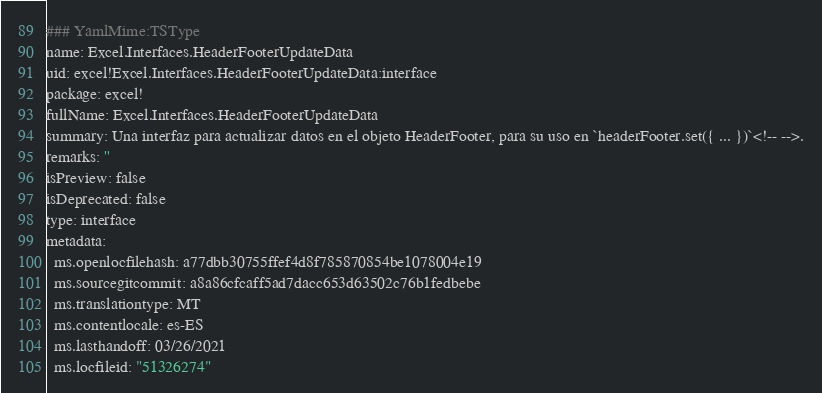<code> <loc_0><loc_0><loc_500><loc_500><_YAML_>### YamlMime:TSType
name: Excel.Interfaces.HeaderFooterUpdateData
uid: excel!Excel.Interfaces.HeaderFooterUpdateData:interface
package: excel!
fullName: Excel.Interfaces.HeaderFooterUpdateData
summary: Una interfaz para actualizar datos en el objeto HeaderFooter, para su uso en `headerFooter.set({ ... })`<!-- -->.
remarks: ''
isPreview: false
isDeprecated: false
type: interface
metadata:
  ms.openlocfilehash: a77dbb30755ffef4d8f785870854be1078004e19
  ms.sourcegitcommit: a8a86cfcaff5ad7dacc653d63502c76b1fedbebe
  ms.translationtype: MT
  ms.contentlocale: es-ES
  ms.lasthandoff: 03/26/2021
  ms.locfileid: "51326274"
</code> 